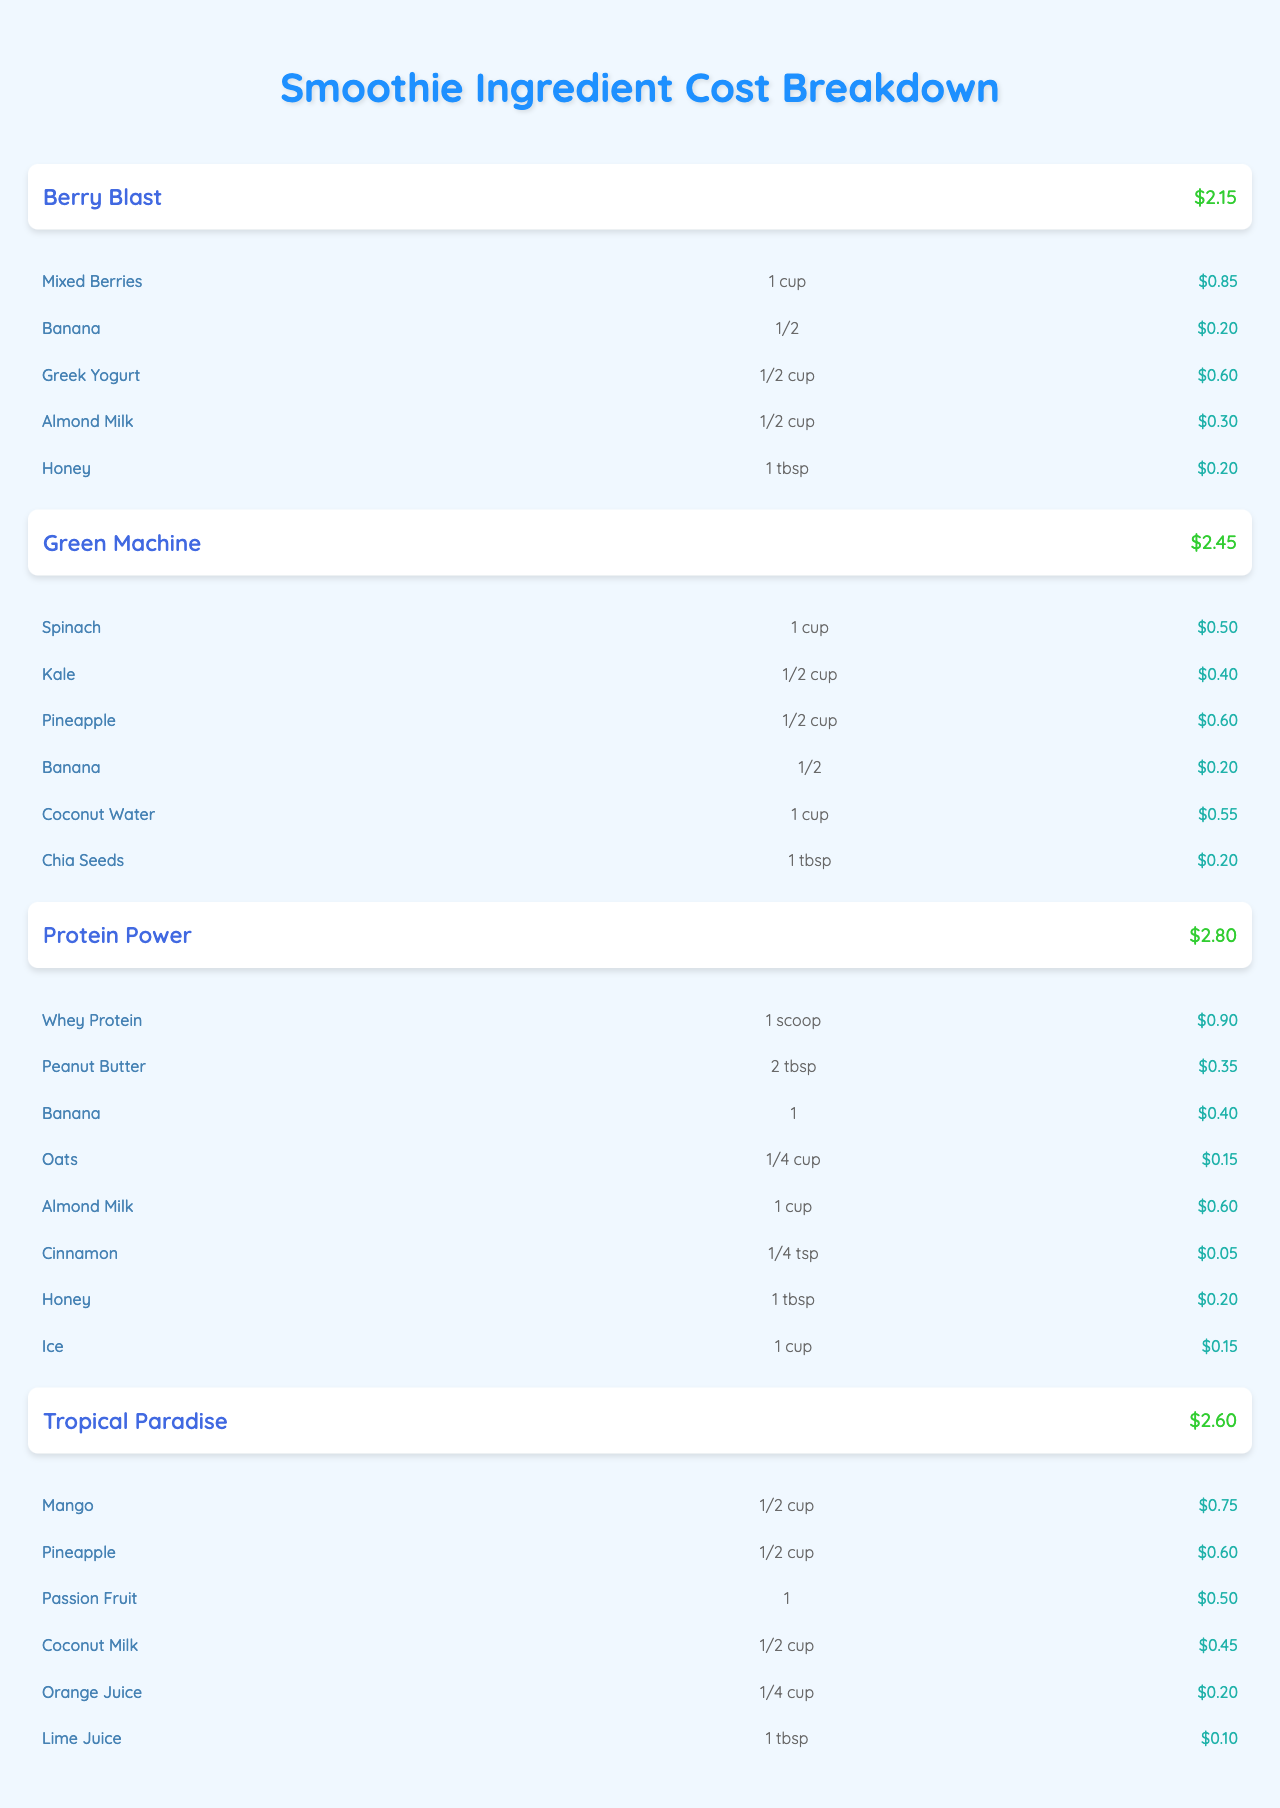What is the total cost of the Berry Blast smoothie? The table lists the Berry Blast smoothie with a total cost of $2.15, directly referencing that specific smoothie.
Answer: $2.15 Which ingredient in the Green Machine smoothie has the highest cost? In the Green Machine smoothie, the ingredients are listed with their respective costs. The highest cost is for Coconut Water at $0.55.
Answer: Coconut Water How much does it cost to make the Protein Power smoothie compared to the Tropical Paradise smoothie? The total cost for Protein Power is $2.80 and for Tropical Paradise is $2.60. The difference in costs is calculated as $2.80 - $2.60 = $0.20.
Answer: $0.20 Is the cost of Honey in the Protein Power smoothie the same as in the Berry Blast smoothie? The cost of Honey in Protein Power is $0.20 and in Berry Blast, it is also $0.20. Since both values are equal, the answer is yes.
Answer: Yes What is the combined cost of all ingredients in the Tropical Paradise smoothie? To find the combined cost, we add up all ingredients: $0.75 (Mango) + $0.60 (Pineapple) + $0.50 (Passion Fruit) + $0.45 (Coconut Milk) + $0.20 (Orange Juice) + $0.10 (Lime Juice) = $2.60, which matches the total cost shown.
Answer: $2.60 What is the average cost of ingredients in the Protein Power smoothie? There are 8 ingredients in Protein Power, summing their costs ($0.90 + $0.35 + $0.40 + $0.15 + $0.60 + $0.05 + $0.20 + $0.15) gives $2.80. Dividing the total by the number of ingredients ($2.80/8) provides the average cost of $0.35.
Answer: $0.35 How does the total cost of the Green Machine smoothie compare to the total cost of the Berry Blast smoothie? The total cost for the Green Machine is $2.45 and for Berry Blast, it is $2.15. The Green Machine is $0.30 more expensive than Berry Blast.
Answer: $0.30 Which smoothie has the lowest total cost? The total costs of all smoothies are compared: $2.15 (Berry Blast), $2.45 (Green Machine), $2.80 (Protein Power), and $2.60 (Tropical Paradise). Berry Blast has the lowest total cost at $2.15.
Answer: Berry Blast What is the total number of ingredients used across all smoothies? By counting the number of ingredients listed for each smoothie: 5 (Berry Blast) + 6 (Green Machine) + 8 (Protein Power) + 6 (Tropical Paradise), the total is 5 + 6 + 8 + 6 = 25 ingredients.
Answer: 25 Are bananas included in all smoothies? The table shows that Banana is an ingredient in Berry Blast, Green Machine, and Protein Power, but it is not included in the Tropical Paradise smoothie. Hence, the answer is no.
Answer: No 